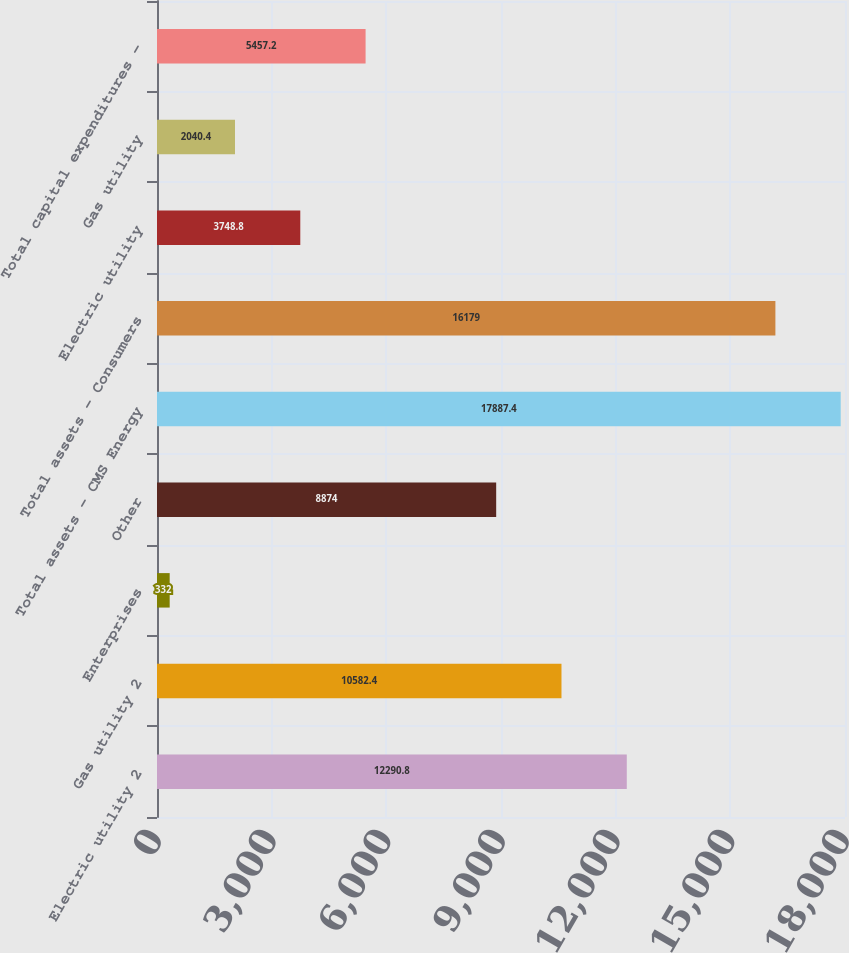Convert chart to OTSL. <chart><loc_0><loc_0><loc_500><loc_500><bar_chart><fcel>Electric utility 2<fcel>Gas utility 2<fcel>Enterprises<fcel>Other<fcel>Total assets - CMS Energy<fcel>Total assets - Consumers<fcel>Electric utility<fcel>Gas utility<fcel>Total capital expenditures -<nl><fcel>12290.8<fcel>10582.4<fcel>332<fcel>8874<fcel>17887.4<fcel>16179<fcel>3748.8<fcel>2040.4<fcel>5457.2<nl></chart> 